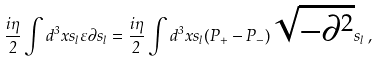Convert formula to latex. <formula><loc_0><loc_0><loc_500><loc_500>\frac { i \eta } 2 \int d ^ { 3 } x s _ { l } \varepsilon \partial s _ { l } = \frac { i \eta } 2 \int d ^ { 3 } x s _ { l } ( P _ { + } - P _ { - } ) \sqrt { - \partial ^ { 2 } } s _ { l } \, ,</formula> 